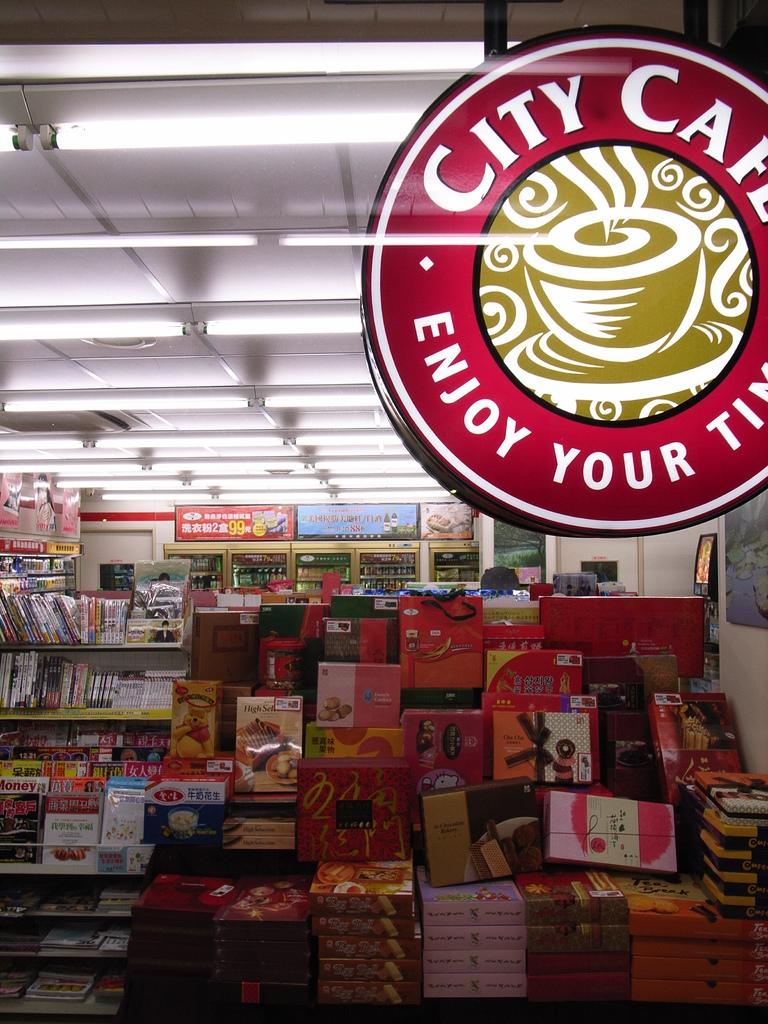Provide a one-sentence caption for the provided image. A City Cafe sign hangs above a mountain of chocolate boxes. 